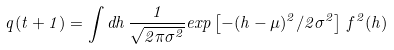<formula> <loc_0><loc_0><loc_500><loc_500>q ( t + 1 ) = \int d h \, { \frac { 1 } { \sqrt { 2 \pi \sigma ^ { 2 } } } } e x p \left [ - ( h - \mu ) ^ { 2 } / { 2 \sigma ^ { 2 } } \right ] \, f ^ { 2 } ( h )</formula> 